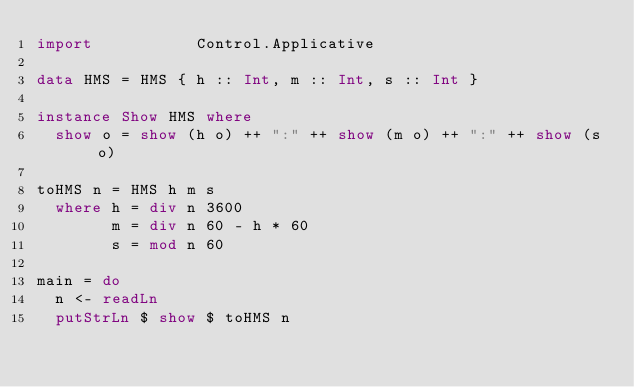<code> <loc_0><loc_0><loc_500><loc_500><_Haskell_>import           Control.Applicative

data HMS = HMS { h :: Int, m :: Int, s :: Int }

instance Show HMS where
  show o = show (h o) ++ ":" ++ show (m o) ++ ":" ++ show (s o)

toHMS n = HMS h m s
  where h = div n 3600
        m = div n 60 - h * 60
        s = mod n 60

main = do
  n <- readLn
  putStrLn $ show $ toHMS n

</code> 